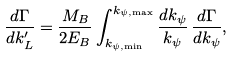<formula> <loc_0><loc_0><loc_500><loc_500>\frac { d \Gamma } { d k _ { L } ^ { \prime } } = \frac { M _ { B } } { 2 E _ { B } } \int _ { k _ { \psi , \min } } ^ { k _ { \psi , \max } } \frac { d k _ { \psi } } { k _ { \psi } } \, \frac { d \Gamma } { d k _ { \psi } } ,</formula> 